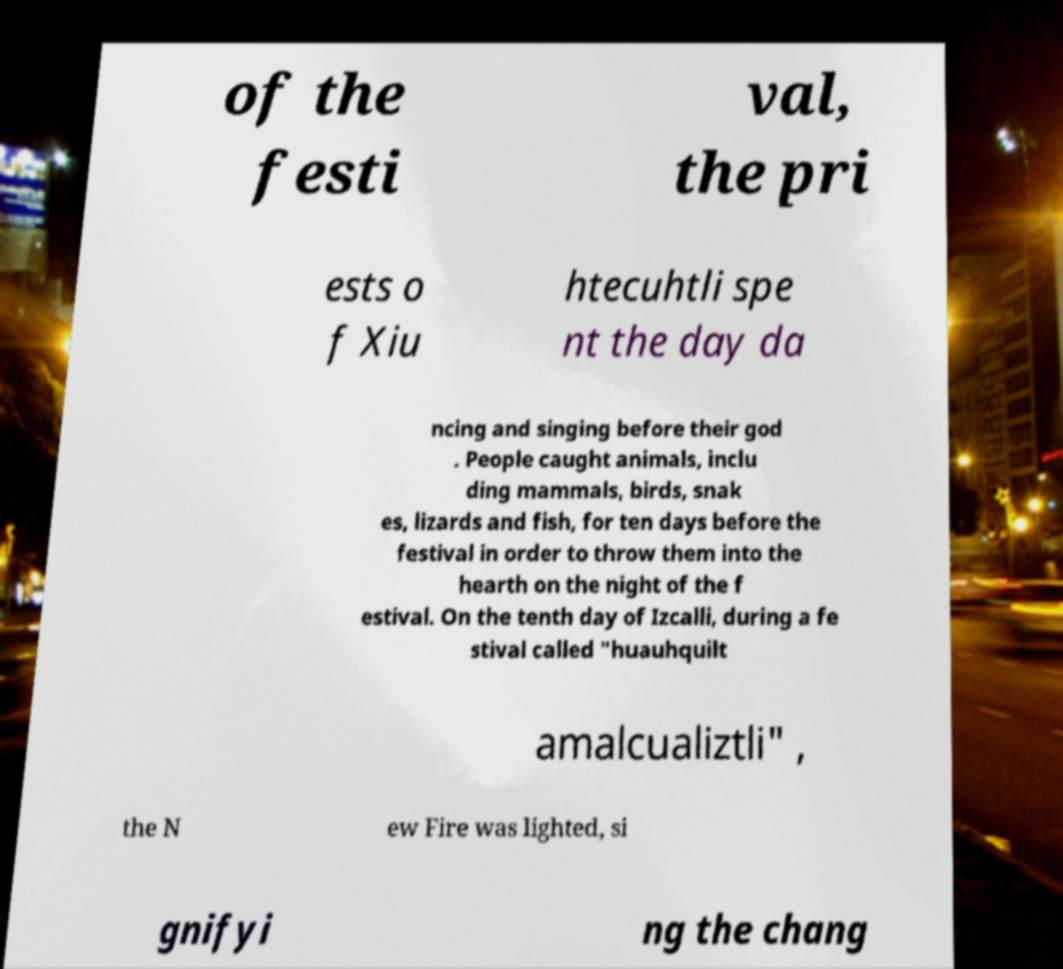Can you read and provide the text displayed in the image?This photo seems to have some interesting text. Can you extract and type it out for me? of the festi val, the pri ests o f Xiu htecuhtli spe nt the day da ncing and singing before their god . People caught animals, inclu ding mammals, birds, snak es, lizards and fish, for ten days before the festival in order to throw them into the hearth on the night of the f estival. On the tenth day of Izcalli, during a fe stival called "huauhquilt amalcualiztli" , the N ew Fire was lighted, si gnifyi ng the chang 